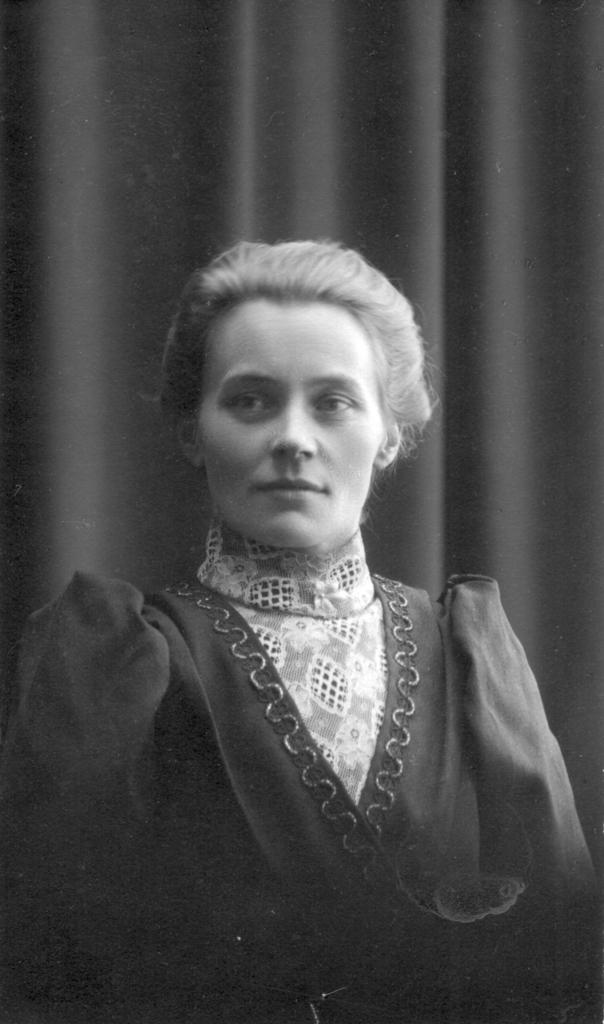What is the color scheme of the image? The image is black and white. Can you describe the main subject in the image? There is a lady in the image. What can be seen in the background of the image? There is a cloth visible in the background of the image. What type of treatment does the lady receive from the fairies in the image? There are no fairies present in the image, so the lady does not receive any treatment from them. 